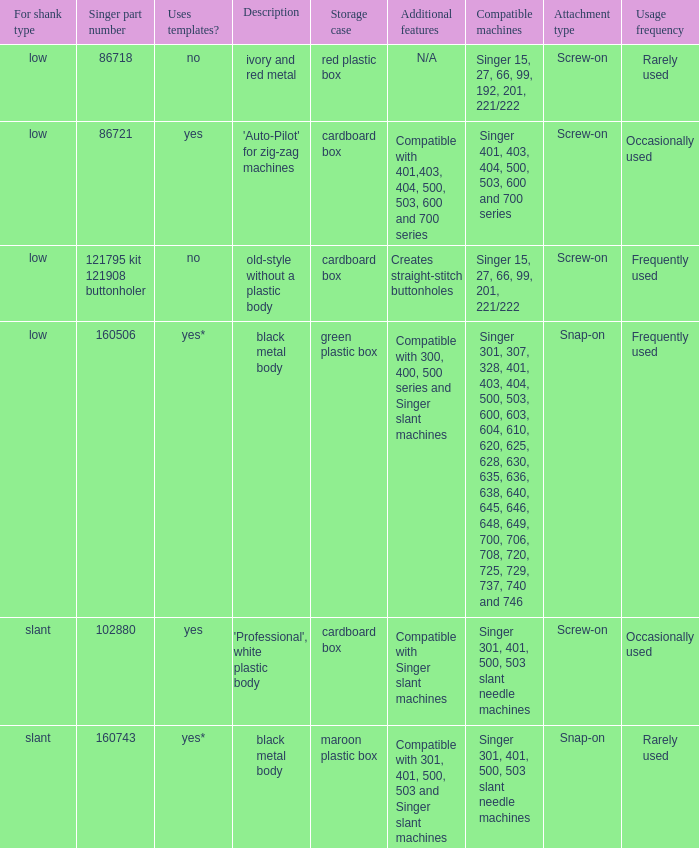What's the description of the buttonholer whose singer part number is 121795 kit 121908 buttonholer? Old-style without a plastic body. 